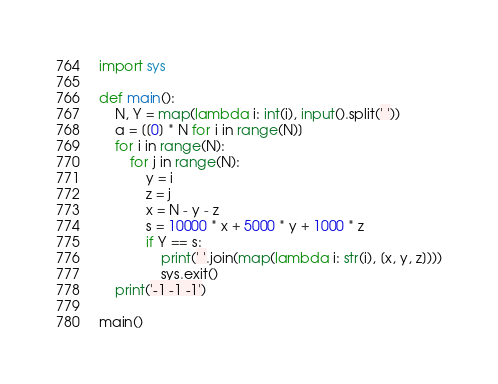<code> <loc_0><loc_0><loc_500><loc_500><_Python_>import sys

def main():
    N, Y = map(lambda i: int(i), input().split(' '))
    a = [[0] * N for i in range(N)]
    for i in range(N):
        for j in range(N):
            y = i
            z = j
            x = N - y - z
            s = 10000 * x + 5000 * y + 1000 * z
            if Y == s:
                print(' '.join(map(lambda i: str(i), [x, y, z])))
                sys.exit()
    print('-1 -1 -1')

main()
</code> 